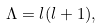<formula> <loc_0><loc_0><loc_500><loc_500>\Lambda = l ( l + 1 ) ,</formula> 